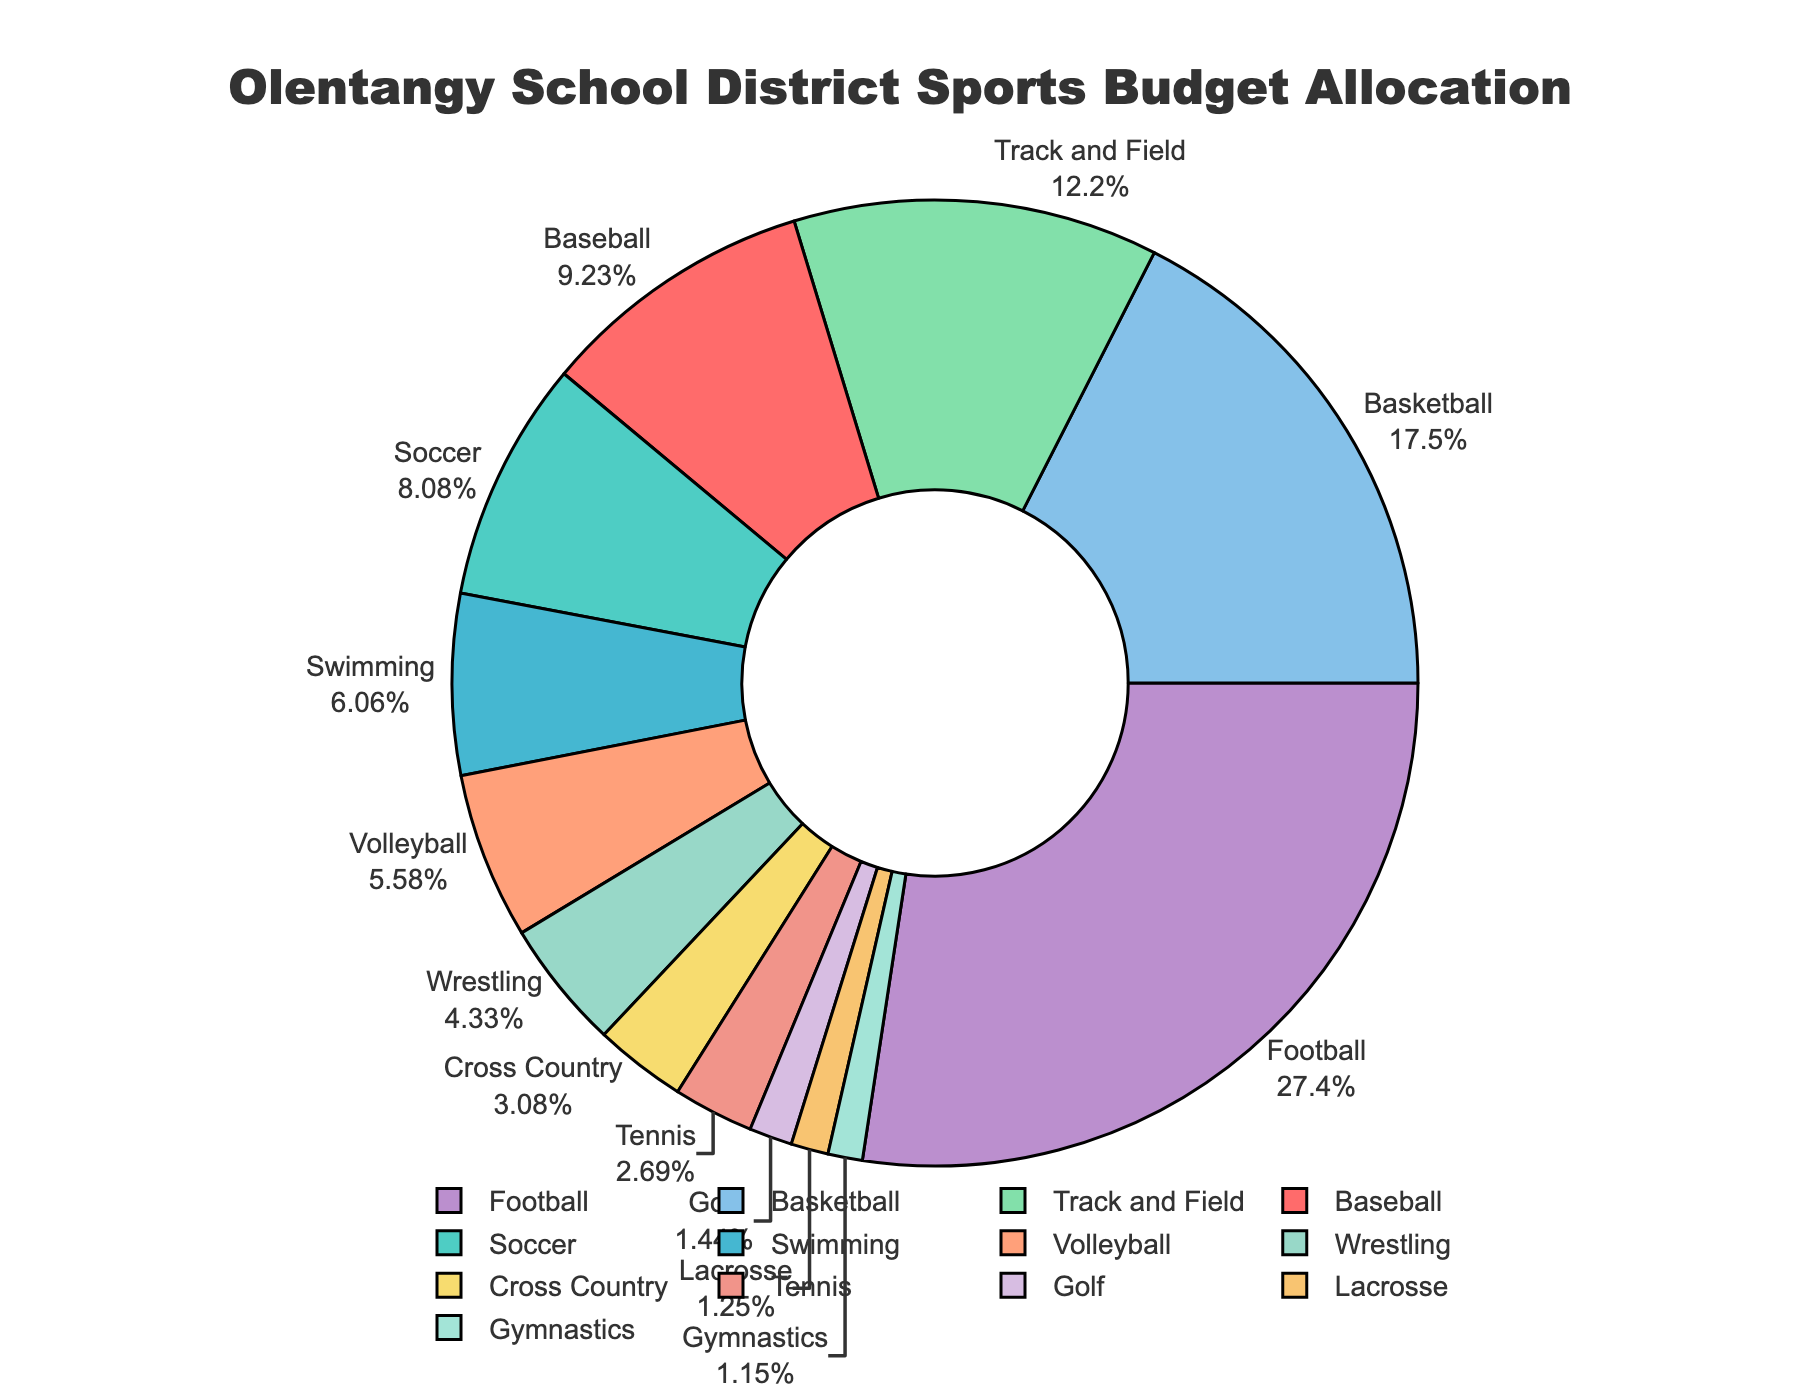What sport receives the highest budget allocation? The figure shows that Football receives the largest portion of the budget, indicated by the largest segment of the pie chart.
Answer: Football Which two sports have the smallest budget allocations? By examining the smallest segments in the pie chart, we see that Gymnastics and Lacrosse have the smallest budget allocations.
Answer: Gymnastics and Lacrosse What is the combined budget allocation for Soccer and Swimming? Adding the percentages for Soccer (8.4%) and Swimming (6.3%) gives 8.4% + 6.3% = 14.7%.
Answer: 14.7% How much more budget is allocated to Football compared to Basketball? Football is allocated 28.5%, and Basketball is allocated 18.2%. The difference is 28.5% - 18.2% = 10.3%.
Answer: 10.3% Which sport has a higher budget allocation, Volleyball or Wrestling? By comparing the sizes of the segments, Volleyball has a budget allocation of 5.8%, which is higher than Wrestling's 4.5%.
Answer: Volleyball Is the budget allocation for Track and Field more than twice that of Tennis? Track and Field has 12.7%, and Tennis has 2.8%. Doubling Tennis's budget allocation gives 2.8% * 2 = 5.6%, which is less than Track and Field's allocation.
Answer: Yes How many sports have a budget allocation greater than 10%? Referring to the pie chart, Football, Basketball, and Track and Field each have a budget allocation greater than 10%.
Answer: 3 sports What is the combined budget allocation for the top three sports? The top three sports are Football (28.5%), Basketball (18.2%), and Track and Field (12.7%). Summing these gives 28.5% + 18.2% + 12.7% = 59.4%.
Answer: 59.4% What is the average budget allocation for the sports listed in the pie chart? Sum all the budget allocations and divide by the number of sports. The sum is 28.5 + 18.2 + 12.7 + 9.6 + 8.4 + 6.3 + 5.8 + 4.5 + 3.2 + 2.8 + 1.5 + 1.3 + 1.2 = 104%. There are 13 sports, so the average is 104% / 13 ≈ 8%.
Answer: 8% Is there any sport with a budget allocation close to 10%? Examining the pie chart, Baseball has a budget allocation of 9.6%, which is close to 10%.
Answer: Baseball 